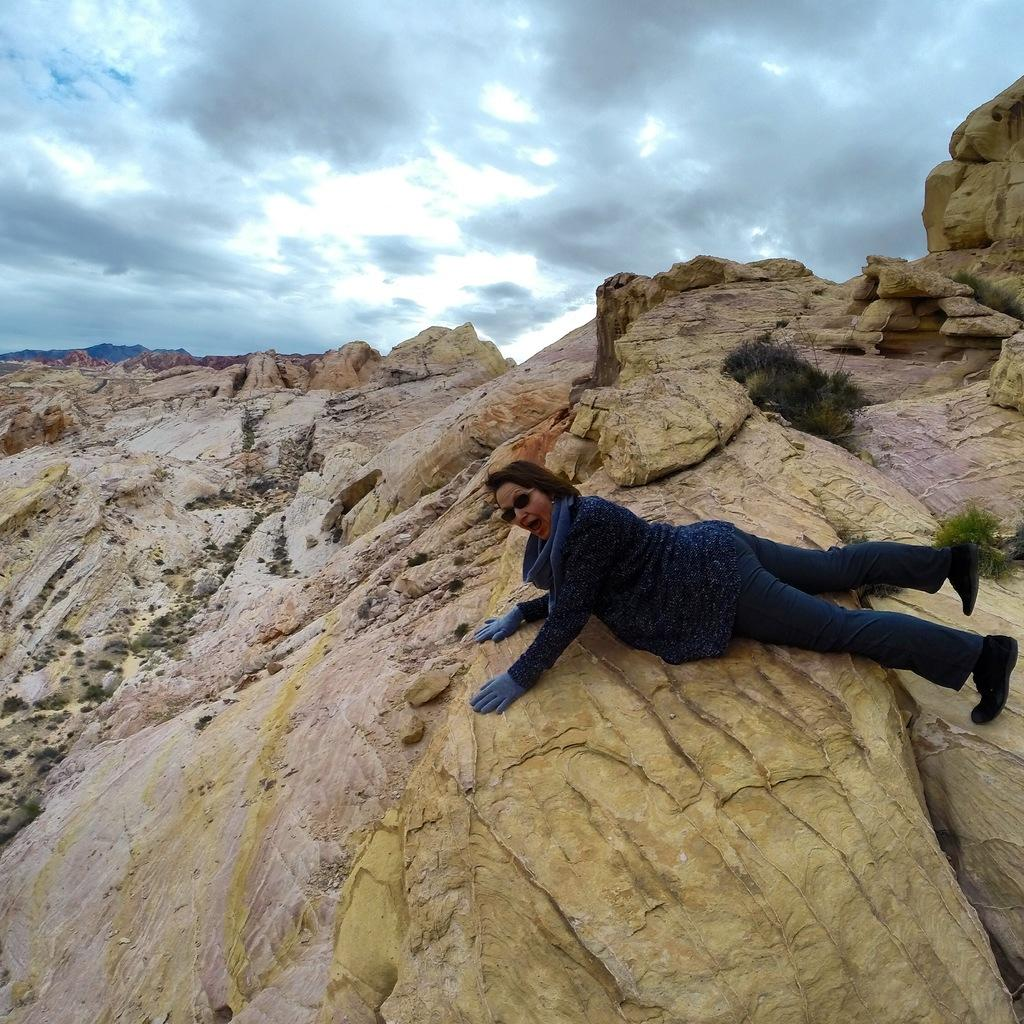What type of surface is in the front of the image? There is a rock surface in the front of the image. What type of vegetation is in the front of the image? There is grass in the front of the image. Is there a person visible in the image? Yes, there is a person in the front of the image. What is visible at the top of the image? The sky is visible at the top of the image. What is the condition of the sky in the image? The sky is cloudy in the image. How many babies are crawling on the rock surface in the image? There are no babies present in the image; it features a person, grass, and a rock surface. What type of cork is used to hold the grass in place in the image? There is no cork present in the image, and the grass is not held in place by any such material. 